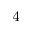<formula> <loc_0><loc_0><loc_500><loc_500>_ { 4 }</formula> 